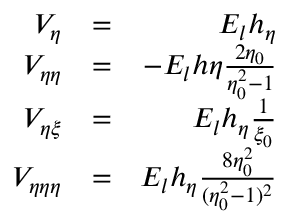<formula> <loc_0><loc_0><loc_500><loc_500>\begin{array} { r l r } { V _ { \eta } } & { = } & { E _ { l } h _ { \eta } } \\ { V _ { \eta \eta } } & { = } & { - E _ { l } h \eta \frac { 2 \eta _ { 0 } } { \eta _ { 0 } ^ { 2 } - 1 } } \\ { V _ { \eta \xi } } & { = } & { E _ { l } h _ { \eta } \frac { 1 } { \xi _ { 0 } } } \\ { V _ { \eta \eta \eta } } & { = } & { E _ { l } h _ { \eta } \frac { 8 \eta _ { 0 } ^ { 2 } } { ( \eta _ { 0 } ^ { 2 } - 1 ) ^ { 2 } } } \end{array}</formula> 